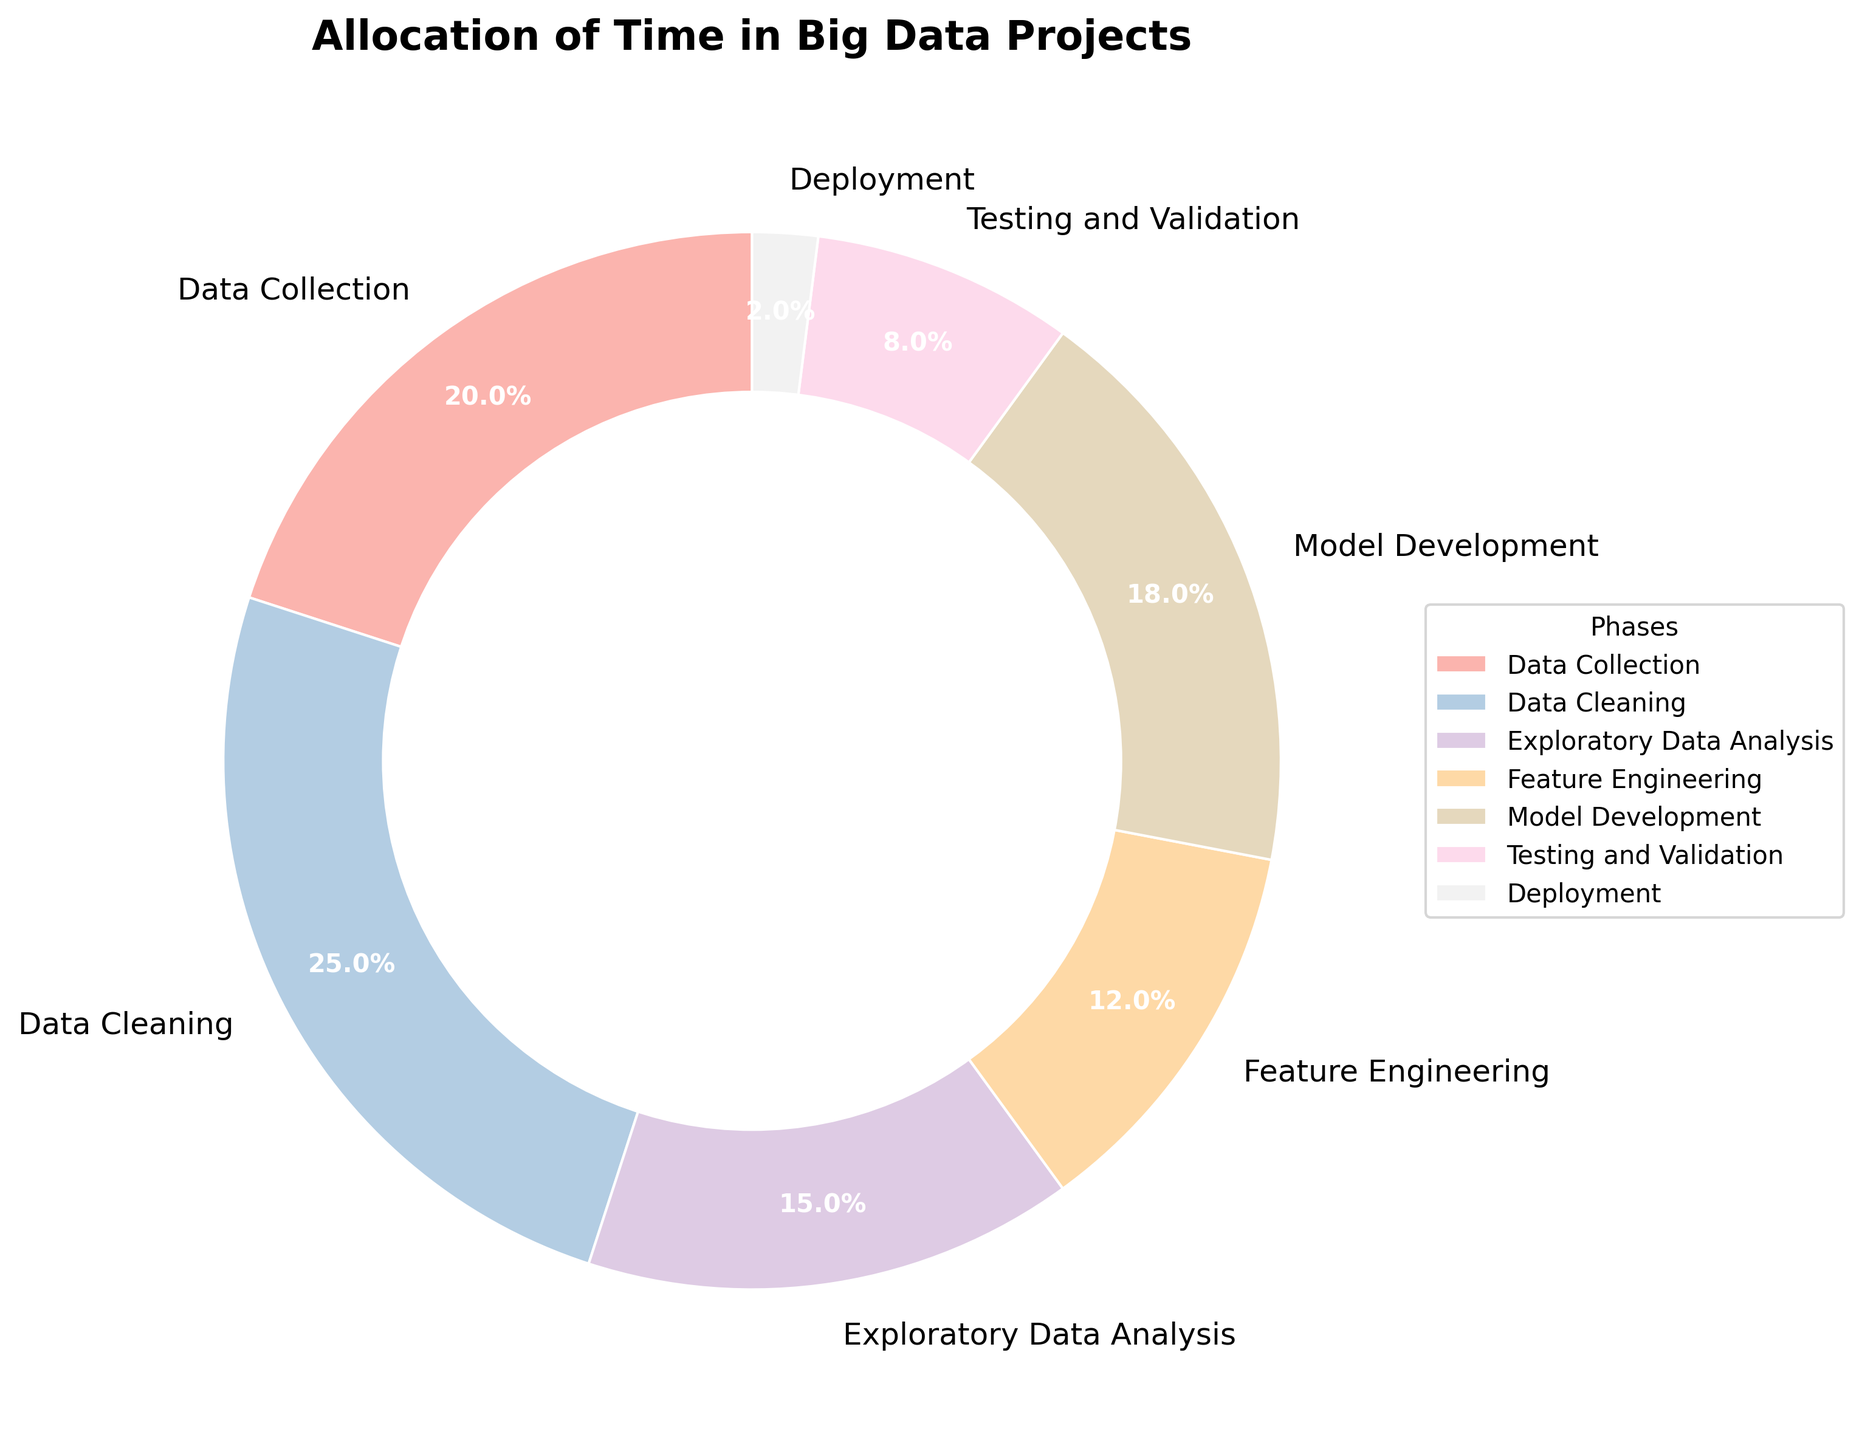What phase occupies the largest percentage of time? By examining the pie chart sectors, identify the phase with the largest wedge. This is indicated by the largest numerical percentage.
Answer: Data Cleaning Which phase takes the least amount of time? Look for the smallest wedge in the pie chart and find the associated label. This phase has the smallest percentage value.
Answer: Deployment What is the combined percentage of Data Collection and Model Development? Sum the percentages of Data Collection (20%) and Model Development (18%). 20 + 18 = 38.
Answer: 38% Compare the time allocated to Data Cleaning and Testing and Validation. Which one is larger, and by how much? Data Cleaning is 25% and Testing and Validation is 8%. Subtract the smaller value from the larger one: 25 - 8 = 17. Data Cleaning takes 17% more time.
Answer: Data Cleaning by 17% How does the time spent on Exploratory Data Analysis compare with Feature Engineering? Exploratory Data Analysis takes 15% and Feature Engineering takes 12%. Compare these values directly: 15 - 12 = 3.
Answer: 3% more What is the ratio of time spent on Deployment to Testing and Validation? Deployment is 2% and Testing and Validation is 8%. Divide the smaller percentage by the larger percentage: 2/8 = 0.25.
Answer: 0.25 Which two phases together make up exactly half of the total time spent? Find out which two percentages total 50% by examining the pie chart's labels and their values. Data Collection is 20% and Data Cleaning is 25%; adding these gives 45%. Add Model Development's 18%, but skip if > 50%. Adding Feature Engineering's 12% gives a total of 20 + 12 = 32%, not 50%. Add Exploratory Data Analysis's 15%, verifying each combination until finding that Data Cleaning (25%) and Feature Engineering (25%) = 50%. 25 + 25 = 50%.
Answer: None What is the aggregate percentage of phases related to pre-modeling (Data Collection, Data Cleaning, and Exploratory Data Analysis)? Sum the percentages for Data Collection (20%), Data Cleaning (25%), and Exploratory Data Analysis (15%). 20 + 25 + 15 = 60.
Answer: 60% What is the percentage difference between Model Development and Feature Engineering? Model Development is 18% and Feature Engineering is 12%. Subtract the smaller value from the larger one: 18 - 12 = 6.
Answer: 6% What do the colors in the pie chart represent? The colors in the pie chart are used to differentiate between the phases of the project. Each phase is likely represented by a distinct color to visually separate them.
Answer: Different phases 